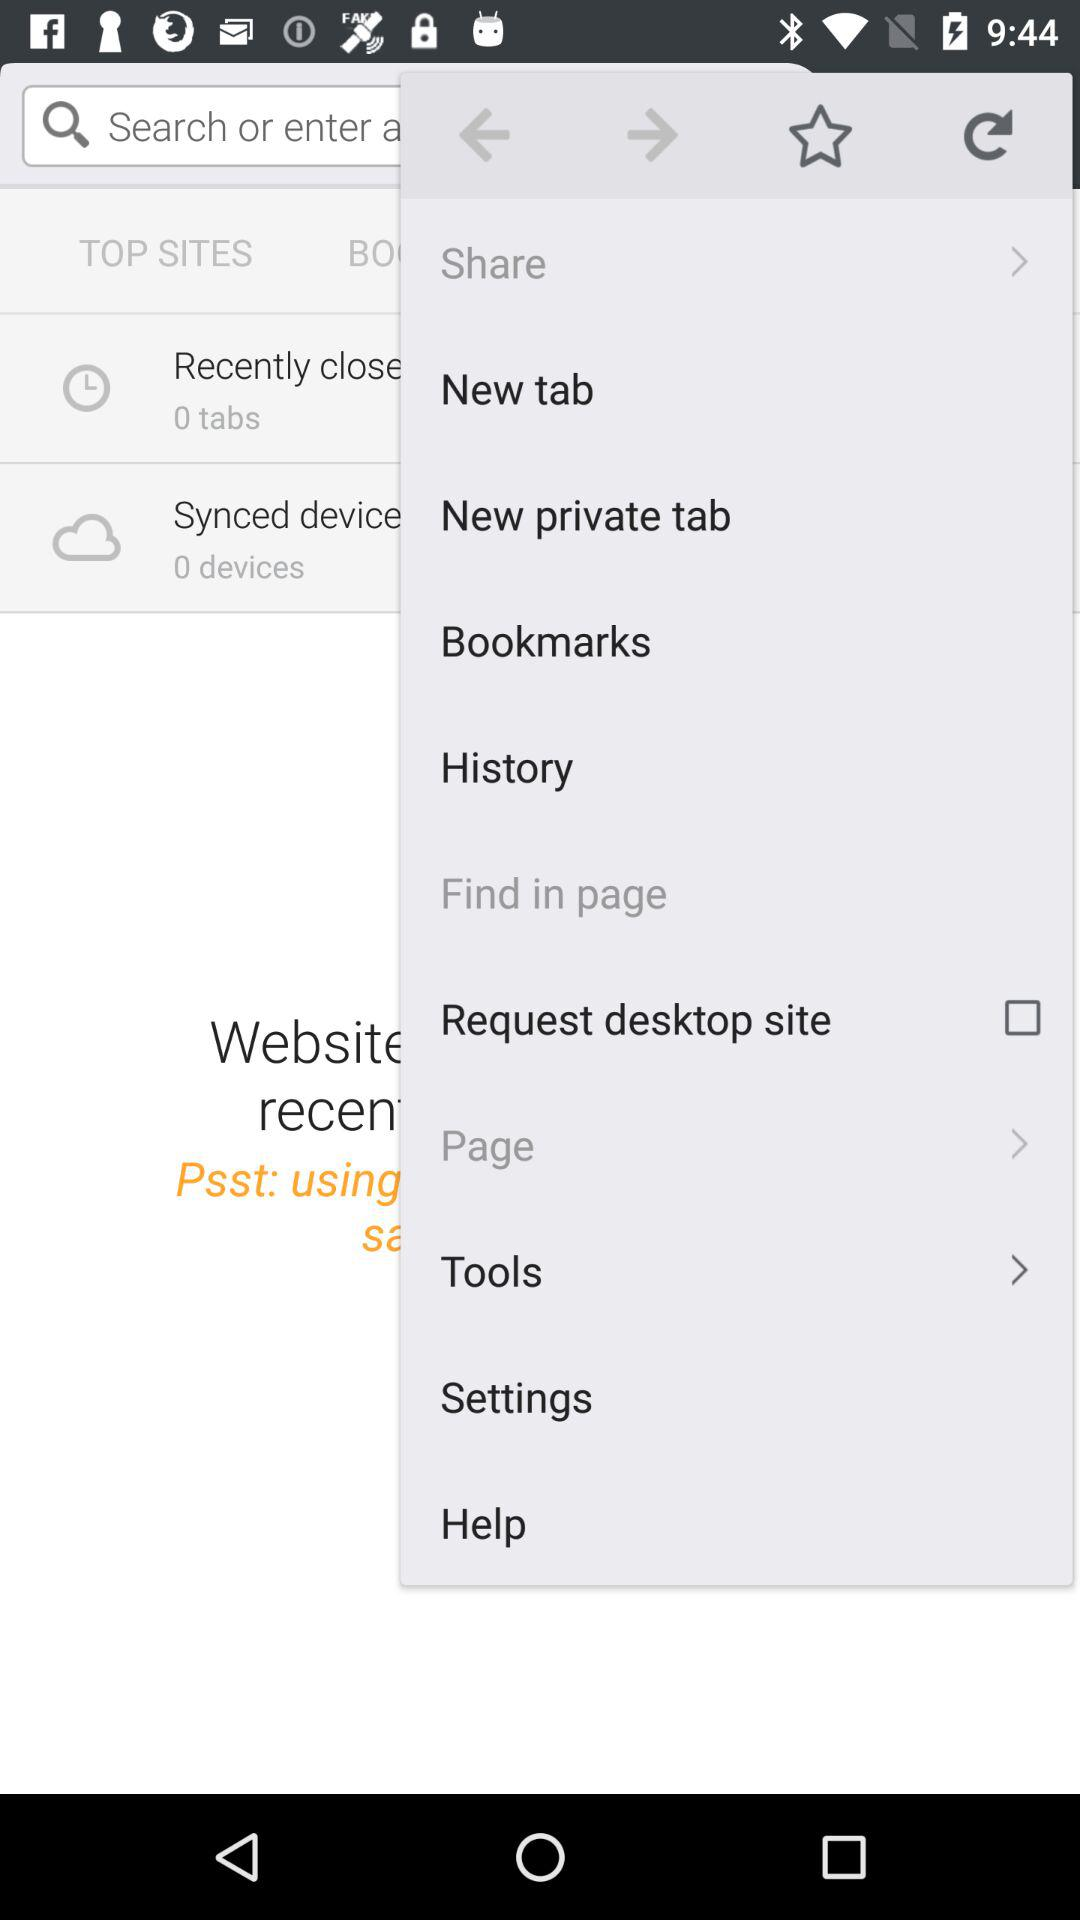What is the status of the "Request desktop site"? The status is "off". 